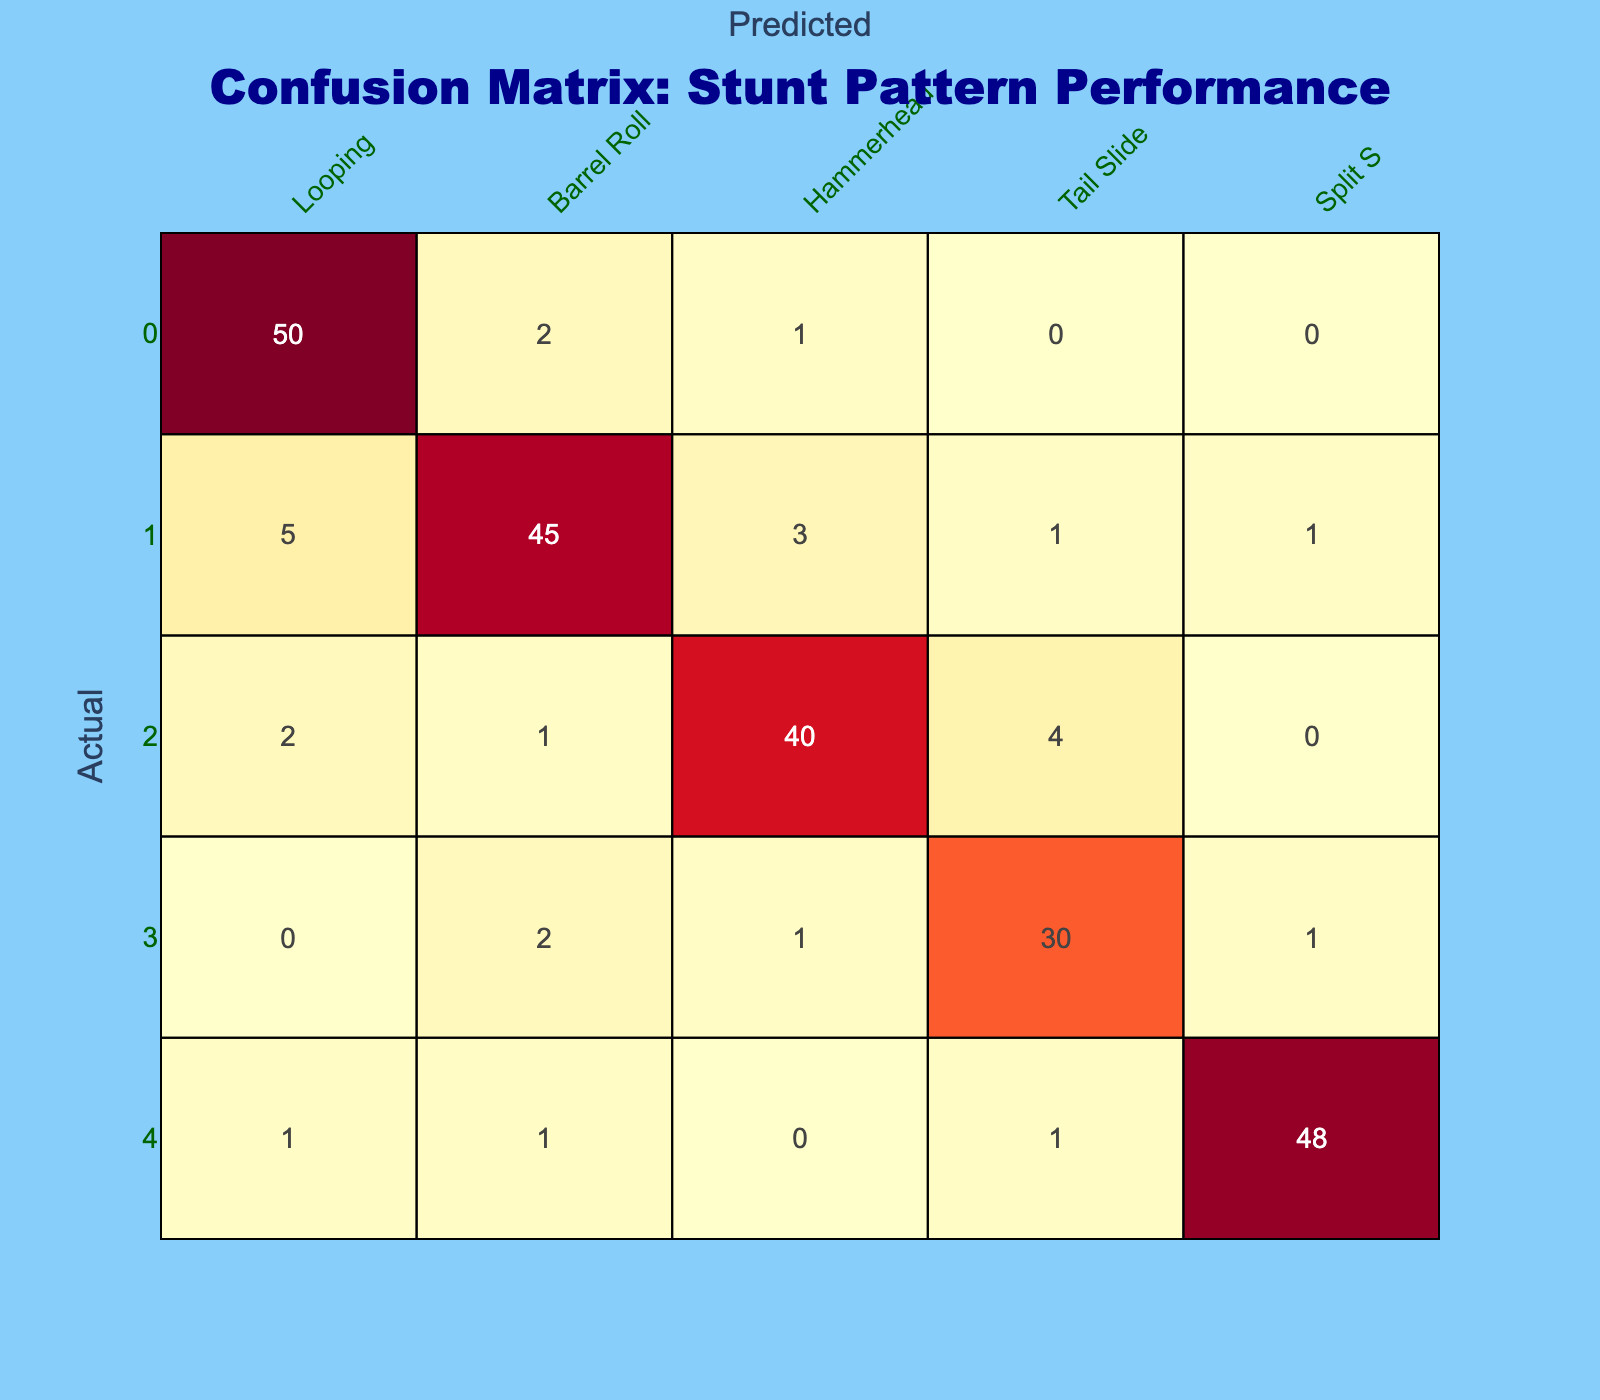What is the total number of correctly predicted Looping stunt patterns? The correctly predicted Looping stunt patterns are located in the first row of the table under the Looping column. The value there is 50.
Answer: 50 What is the percentage of incorrectly predicted Barrel Roll outcomes? To find the percentage of incorrectly predicted Barrel Roll outcomes, we first need to find the total for Barrel Roll, which is 55 (sum of the second row). The incorrectly predicted counts are 5 (Looping) + 3 (Hammerhead) + 1 (Tail Slide) + 1 (Split S) = 10. Thus, the percentage is (10 / 55) * 100 = approximately 18.18%.
Answer: 18.18% Which stunt pattern has the highest number of incorrect predictions? To determine which stunt pattern has the highest number of incorrect predictions, we can sum the rows of the table to get the total misclassifications for each pattern. The sums are as follows: Looping (8), Barrel Roll (10), Hammerhead (7), Tail Slide (4), and Split S (3). Therefore, Barrel Roll has the highest at 10.
Answer: Barrel Roll Is the number of correctly predicted Hammerhead patterns greater than that of correctly predicted Tail Slide patterns? The correctly predicted Hammerhead patterns are 40, and the correctly predicted Tail Slide patterns are 30. Since 40 is greater than 30, the answer is yes.
Answer: Yes What is the average number of incorrectly predicted patterns across all stunt types? To calculate the average number of incorrectly predicted patterns, we first need to sum all the misclassifications: Looping (8), Barrel Roll (10), Hammerhead (7), Tail Slide (4), and Split S (3), resulting in a total of 32. There are 5 stunt types, so the average is 32 / 5 = 6.4.
Answer: 6.4 Which stunt pattern is the least confusing in terms of prediction, and how do you know? The least confusing stunt pattern is the Split S, as it has the lowest number of incorrect predictions which total 3 (1 for Looping, 1 for Barrel Roll, 1 for Tail Slide). This indicates that it is most often correctly predicted.
Answer: Split S Total number of predictions made for the Hammerhead stunt pattern? To find the total predictions made for the Hammerhead stunt pattern, we sum the values from the Hammerhead column: 1 (Looping) + 3 (Barrel Roll) + 4 (Tail Slide) + 0 (Split S) + 40 (Hammerhead) = 48.
Answer: 48 How many more Looping patterns were correctly predicted compared to Split S? The number of correctly predicted Looping patterns is 50, while for Split S, it is 48. The difference is 50 - 48 = 2. Hence, there are 2 more correctly predicted Looping patterns.
Answer: 2 What proportion of the total predictions are for Barrel Roll? The total predictions can be calculated as the sum of all values in the table: 50 + 2 + 1 + 0 + 0 + 5 + 45 + 3 + 1 + 1 + 2 + 1 + 40 + 4 + 0 + 0 + 0 + 2 + 1 + 30 + 1 + 1 + 1 + 48 = 205. The total for Barrel Roll alone is 5 + 45 + 3 + 1 + 1 = 55. Thus, the proportion is 55 / 205 = approximately 0.268.
Answer: 0.268 